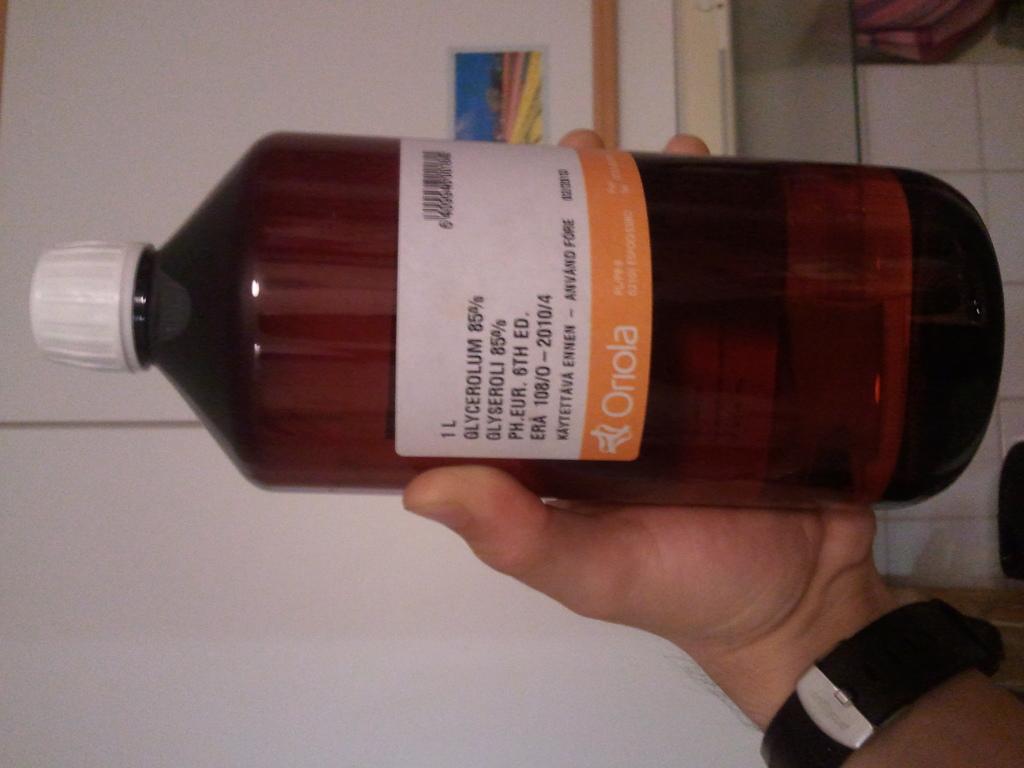How many liters is this bottle?
Your answer should be compact. 1. 